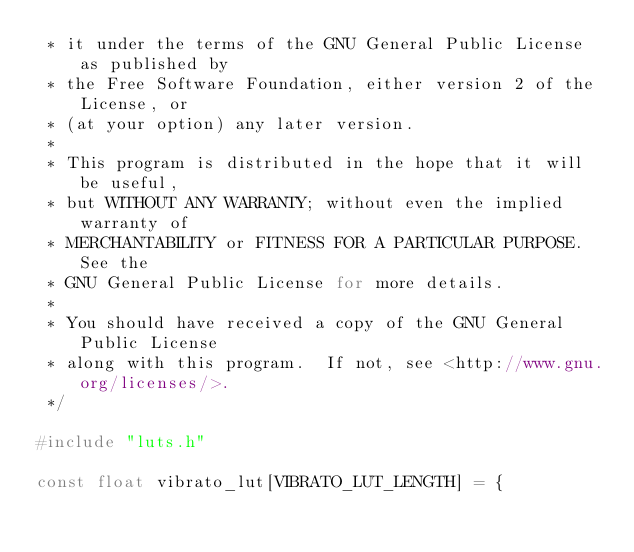<code> <loc_0><loc_0><loc_500><loc_500><_C_> * it under the terms of the GNU General Public License as published by
 * the Free Software Foundation, either version 2 of the License, or
 * (at your option) any later version.
 *
 * This program is distributed in the hope that it will be useful,
 * but WITHOUT ANY WARRANTY; without even the implied warranty of
 * MERCHANTABILITY or FITNESS FOR A PARTICULAR PURPOSE.  See the
 * GNU General Public License for more details.
 *
 * You should have received a copy of the GNU General Public License
 * along with this program.  If not, see <http://www.gnu.org/licenses/>.
 */

#include "luts.h"

const float vibrato_lut[VIBRATO_LUT_LENGTH] = {</code> 